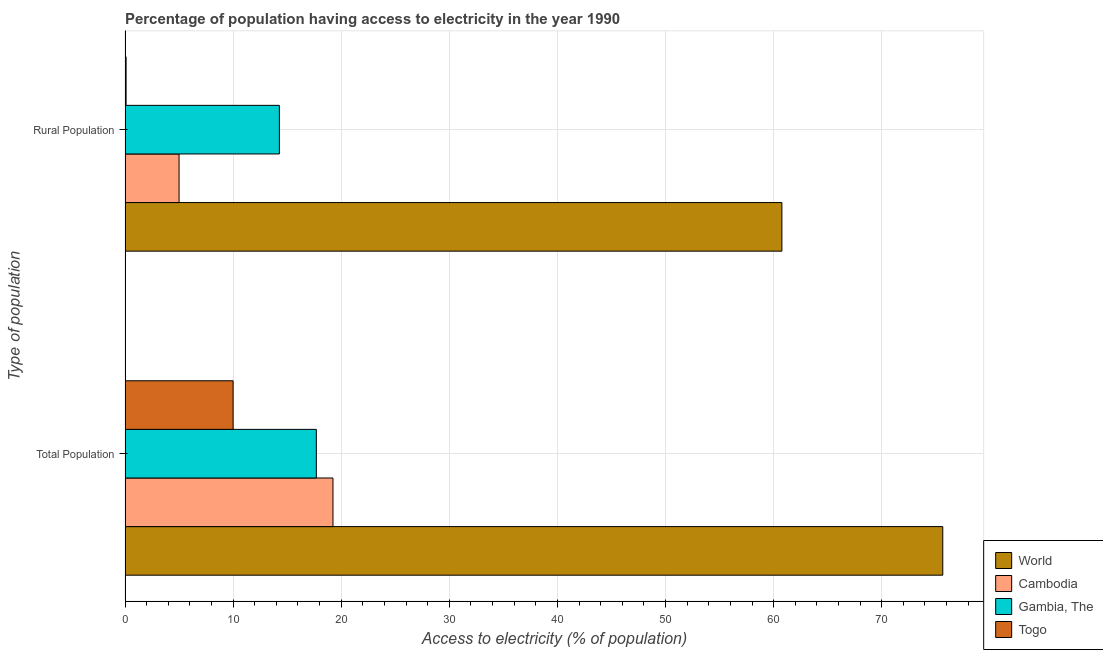How many bars are there on the 1st tick from the bottom?
Ensure brevity in your answer.  4. What is the label of the 1st group of bars from the top?
Ensure brevity in your answer.  Rural Population. What is the percentage of rural population having access to electricity in Gambia, The?
Your response must be concise. 14.28. Across all countries, what is the maximum percentage of population having access to electricity?
Provide a short and direct response. 75.65. In which country was the percentage of rural population having access to electricity minimum?
Provide a succinct answer. Togo. What is the total percentage of rural population having access to electricity in the graph?
Keep it short and to the point. 80.15. What is the difference between the percentage of population having access to electricity in Togo and that in Cambodia?
Provide a short and direct response. -9.24. What is the difference between the percentage of population having access to electricity in Togo and the percentage of rural population having access to electricity in Gambia, The?
Ensure brevity in your answer.  -4.28. What is the average percentage of rural population having access to electricity per country?
Keep it short and to the point. 20.04. What is the difference between the percentage of population having access to electricity and percentage of rural population having access to electricity in Gambia, The?
Provide a succinct answer. 3.42. What is the ratio of the percentage of population having access to electricity in World to that in Togo?
Offer a terse response. 7.56. Is the percentage of rural population having access to electricity in Gambia, The less than that in Togo?
Ensure brevity in your answer.  No. In how many countries, is the percentage of population having access to electricity greater than the average percentage of population having access to electricity taken over all countries?
Provide a succinct answer. 1. What does the 4th bar from the bottom in Rural Population represents?
Your response must be concise. Togo. How many bars are there?
Make the answer very short. 8. Are all the bars in the graph horizontal?
Your answer should be very brief. Yes. How many countries are there in the graph?
Ensure brevity in your answer.  4. What is the difference between two consecutive major ticks on the X-axis?
Make the answer very short. 10. How many legend labels are there?
Provide a short and direct response. 4. How are the legend labels stacked?
Your answer should be compact. Vertical. What is the title of the graph?
Your response must be concise. Percentage of population having access to electricity in the year 1990. Does "European Union" appear as one of the legend labels in the graph?
Your answer should be compact. No. What is the label or title of the X-axis?
Your answer should be very brief. Access to electricity (% of population). What is the label or title of the Y-axis?
Provide a succinct answer. Type of population. What is the Access to electricity (% of population) of World in Total Population?
Provide a succinct answer. 75.65. What is the Access to electricity (% of population) in Cambodia in Total Population?
Give a very brief answer. 19.24. What is the Access to electricity (% of population) of Gambia, The in Total Population?
Ensure brevity in your answer.  17.7. What is the Access to electricity (% of population) of Togo in Total Population?
Provide a succinct answer. 10. What is the Access to electricity (% of population) in World in Rural Population?
Provide a short and direct response. 60.77. What is the Access to electricity (% of population) in Cambodia in Rural Population?
Ensure brevity in your answer.  5. What is the Access to electricity (% of population) of Gambia, The in Rural Population?
Provide a succinct answer. 14.28. What is the Access to electricity (% of population) of Togo in Rural Population?
Your answer should be compact. 0.1. Across all Type of population, what is the maximum Access to electricity (% of population) in World?
Your answer should be very brief. 75.65. Across all Type of population, what is the maximum Access to electricity (% of population) in Cambodia?
Your answer should be compact. 19.24. Across all Type of population, what is the minimum Access to electricity (% of population) of World?
Your answer should be compact. 60.77. Across all Type of population, what is the minimum Access to electricity (% of population) in Gambia, The?
Make the answer very short. 14.28. Across all Type of population, what is the minimum Access to electricity (% of population) in Togo?
Keep it short and to the point. 0.1. What is the total Access to electricity (% of population) of World in the graph?
Give a very brief answer. 136.41. What is the total Access to electricity (% of population) of Cambodia in the graph?
Your response must be concise. 24.24. What is the total Access to electricity (% of population) of Gambia, The in the graph?
Your answer should be very brief. 31.98. What is the difference between the Access to electricity (% of population) of World in Total Population and that in Rural Population?
Your response must be concise. 14.88. What is the difference between the Access to electricity (% of population) of Cambodia in Total Population and that in Rural Population?
Ensure brevity in your answer.  14.24. What is the difference between the Access to electricity (% of population) in Gambia, The in Total Population and that in Rural Population?
Provide a short and direct response. 3.42. What is the difference between the Access to electricity (% of population) in Togo in Total Population and that in Rural Population?
Provide a short and direct response. 9.9. What is the difference between the Access to electricity (% of population) of World in Total Population and the Access to electricity (% of population) of Cambodia in Rural Population?
Keep it short and to the point. 70.65. What is the difference between the Access to electricity (% of population) in World in Total Population and the Access to electricity (% of population) in Gambia, The in Rural Population?
Provide a succinct answer. 61.37. What is the difference between the Access to electricity (% of population) of World in Total Population and the Access to electricity (% of population) of Togo in Rural Population?
Your answer should be compact. 75.55. What is the difference between the Access to electricity (% of population) in Cambodia in Total Population and the Access to electricity (% of population) in Gambia, The in Rural Population?
Provide a short and direct response. 4.96. What is the difference between the Access to electricity (% of population) in Cambodia in Total Population and the Access to electricity (% of population) in Togo in Rural Population?
Offer a very short reply. 19.14. What is the difference between the Access to electricity (% of population) in Gambia, The in Total Population and the Access to electricity (% of population) in Togo in Rural Population?
Your answer should be very brief. 17.6. What is the average Access to electricity (% of population) of World per Type of population?
Give a very brief answer. 68.21. What is the average Access to electricity (% of population) of Cambodia per Type of population?
Offer a very short reply. 12.12. What is the average Access to electricity (% of population) of Gambia, The per Type of population?
Provide a short and direct response. 15.99. What is the average Access to electricity (% of population) in Togo per Type of population?
Keep it short and to the point. 5.05. What is the difference between the Access to electricity (% of population) of World and Access to electricity (% of population) of Cambodia in Total Population?
Provide a short and direct response. 56.41. What is the difference between the Access to electricity (% of population) in World and Access to electricity (% of population) in Gambia, The in Total Population?
Your answer should be very brief. 57.95. What is the difference between the Access to electricity (% of population) of World and Access to electricity (% of population) of Togo in Total Population?
Keep it short and to the point. 65.65. What is the difference between the Access to electricity (% of population) of Cambodia and Access to electricity (% of population) of Gambia, The in Total Population?
Your response must be concise. 1.54. What is the difference between the Access to electricity (% of population) in Cambodia and Access to electricity (% of population) in Togo in Total Population?
Provide a succinct answer. 9.24. What is the difference between the Access to electricity (% of population) of Gambia, The and Access to electricity (% of population) of Togo in Total Population?
Your answer should be compact. 7.7. What is the difference between the Access to electricity (% of population) in World and Access to electricity (% of population) in Cambodia in Rural Population?
Your answer should be compact. 55.77. What is the difference between the Access to electricity (% of population) in World and Access to electricity (% of population) in Gambia, The in Rural Population?
Offer a terse response. 46.49. What is the difference between the Access to electricity (% of population) of World and Access to electricity (% of population) of Togo in Rural Population?
Provide a succinct answer. 60.67. What is the difference between the Access to electricity (% of population) in Cambodia and Access to electricity (% of population) in Gambia, The in Rural Population?
Make the answer very short. -9.28. What is the difference between the Access to electricity (% of population) of Gambia, The and Access to electricity (% of population) of Togo in Rural Population?
Ensure brevity in your answer.  14.18. What is the ratio of the Access to electricity (% of population) of World in Total Population to that in Rural Population?
Your answer should be very brief. 1.24. What is the ratio of the Access to electricity (% of population) of Cambodia in Total Population to that in Rural Population?
Give a very brief answer. 3.85. What is the ratio of the Access to electricity (% of population) of Gambia, The in Total Population to that in Rural Population?
Offer a terse response. 1.24. What is the difference between the highest and the second highest Access to electricity (% of population) in World?
Your answer should be compact. 14.88. What is the difference between the highest and the second highest Access to electricity (% of population) of Cambodia?
Offer a very short reply. 14.24. What is the difference between the highest and the second highest Access to electricity (% of population) of Gambia, The?
Ensure brevity in your answer.  3.42. What is the difference between the highest and the lowest Access to electricity (% of population) in World?
Give a very brief answer. 14.88. What is the difference between the highest and the lowest Access to electricity (% of population) of Cambodia?
Your answer should be compact. 14.24. What is the difference between the highest and the lowest Access to electricity (% of population) of Gambia, The?
Your answer should be very brief. 3.42. 